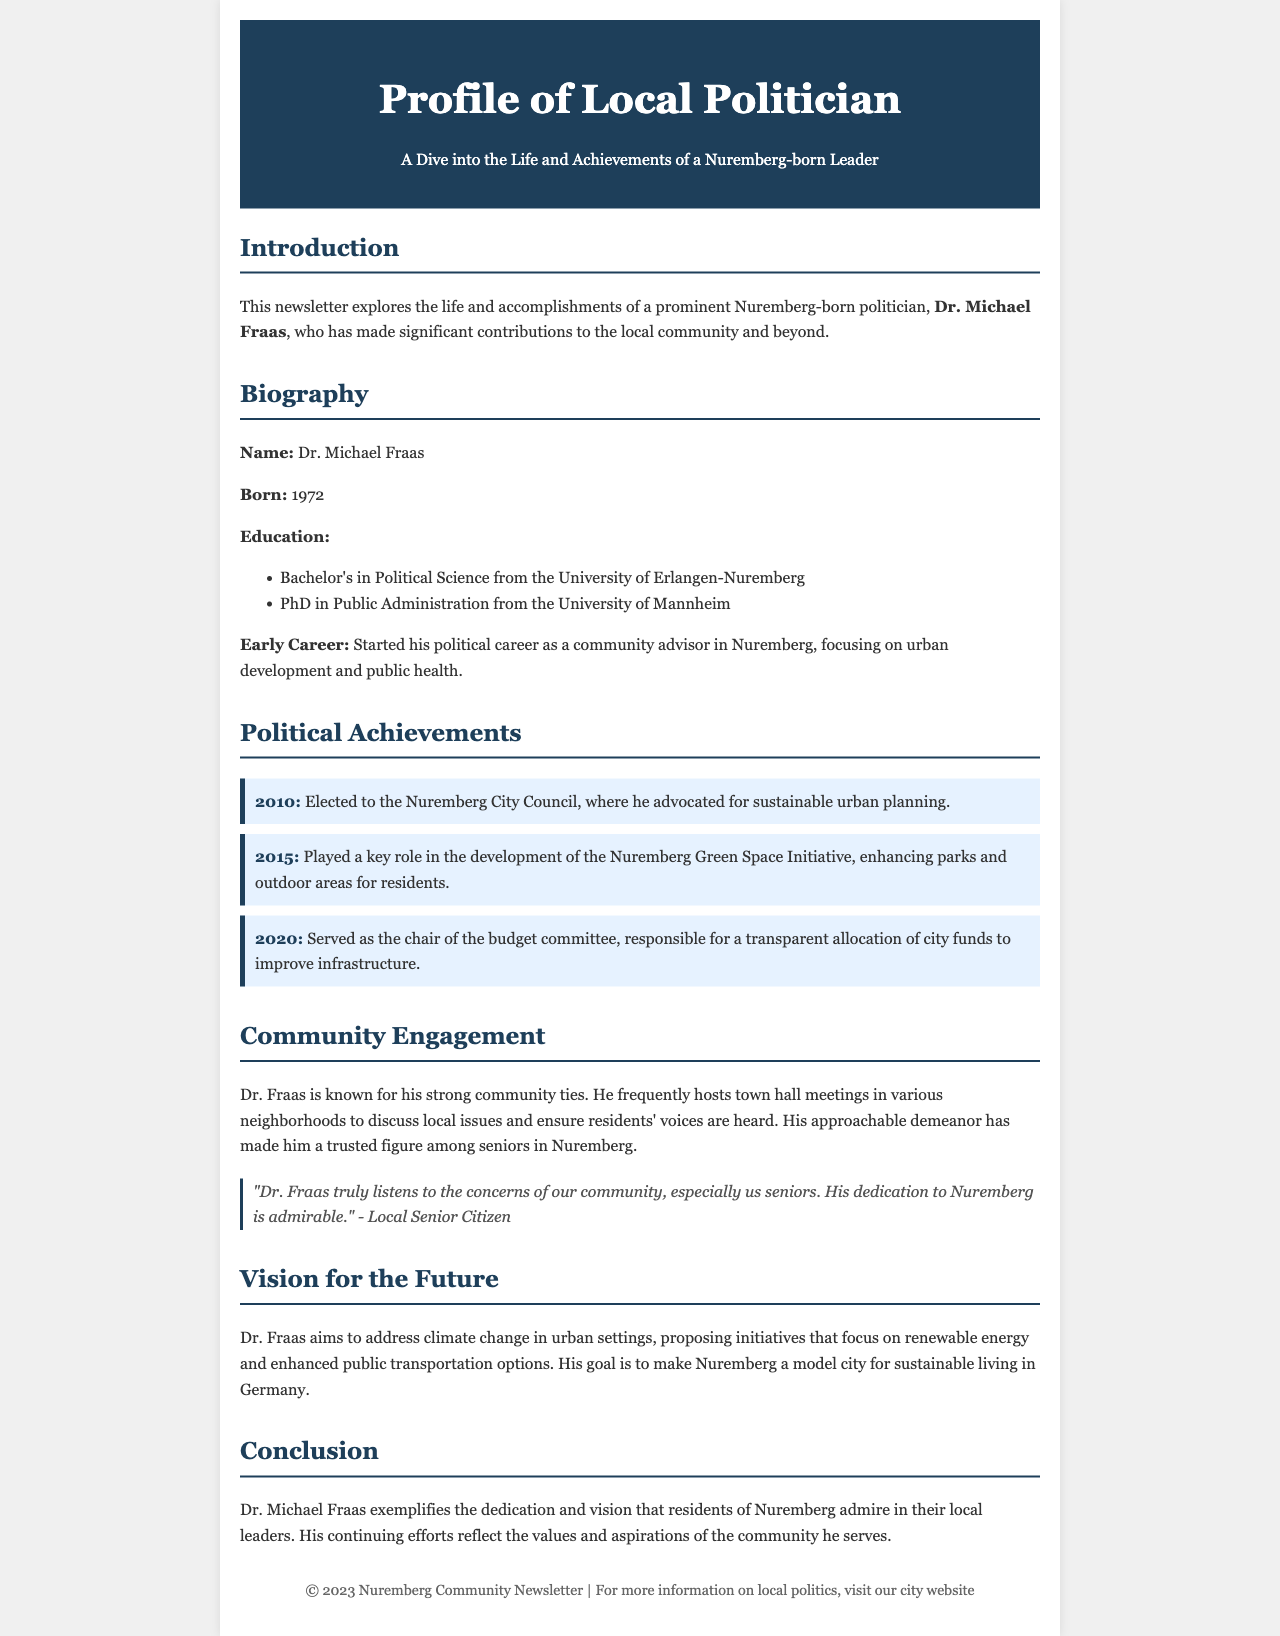What is the name of the featured politician? The document emphasizes Dr. Michael Fraas as the prominent local politician of focus.
Answer: Dr. Michael Fraas When was Dr. Michael Fraas born? The document states Dr. Michael Fraas was born in 1972.
Answer: 1972 Which university did Dr. Fraas attend for his Bachelor's degree? The document specifies that Dr. Fraas earned his Bachelor's in Political Science from the University of Erlangen-Nuremberg.
Answer: University of Erlangen-Nuremberg What initiative did Dr. Fraas play a key role in developing in 2015? According to the document, he was instrumental in the Nuremberg Green Space Initiative, aiming to enhance local parks.
Answer: Nuremberg Green Space Initiative What is Dr. Fraas's vision for the future? The document mentions his intent to address climate change through renewable energy and improved public transportation.
Answer: Address climate change Why is Dr. Fraas considered a trusted figure among seniors? The document illustrates that Dr. Fraas frequently hosts town hall meetings and listens to community concerns, especially from seniors.
Answer: He listens to community concerns In which year was Dr. Fraas elected to the Nuremberg City Council? The document states that Dr. Fraas was elected to the council in 2010, marking the start of his significant political role.
Answer: 2010 What is the primary focus of Dr. Fraas's early career? The document highlights his initial focus on urban development and public health as a community advisor.
Answer: Urban development and public health What is the color scheme of the newsletter's header? The document describes the header color as a dark blue, specifically #1e3f5a.
Answer: Dark blue 